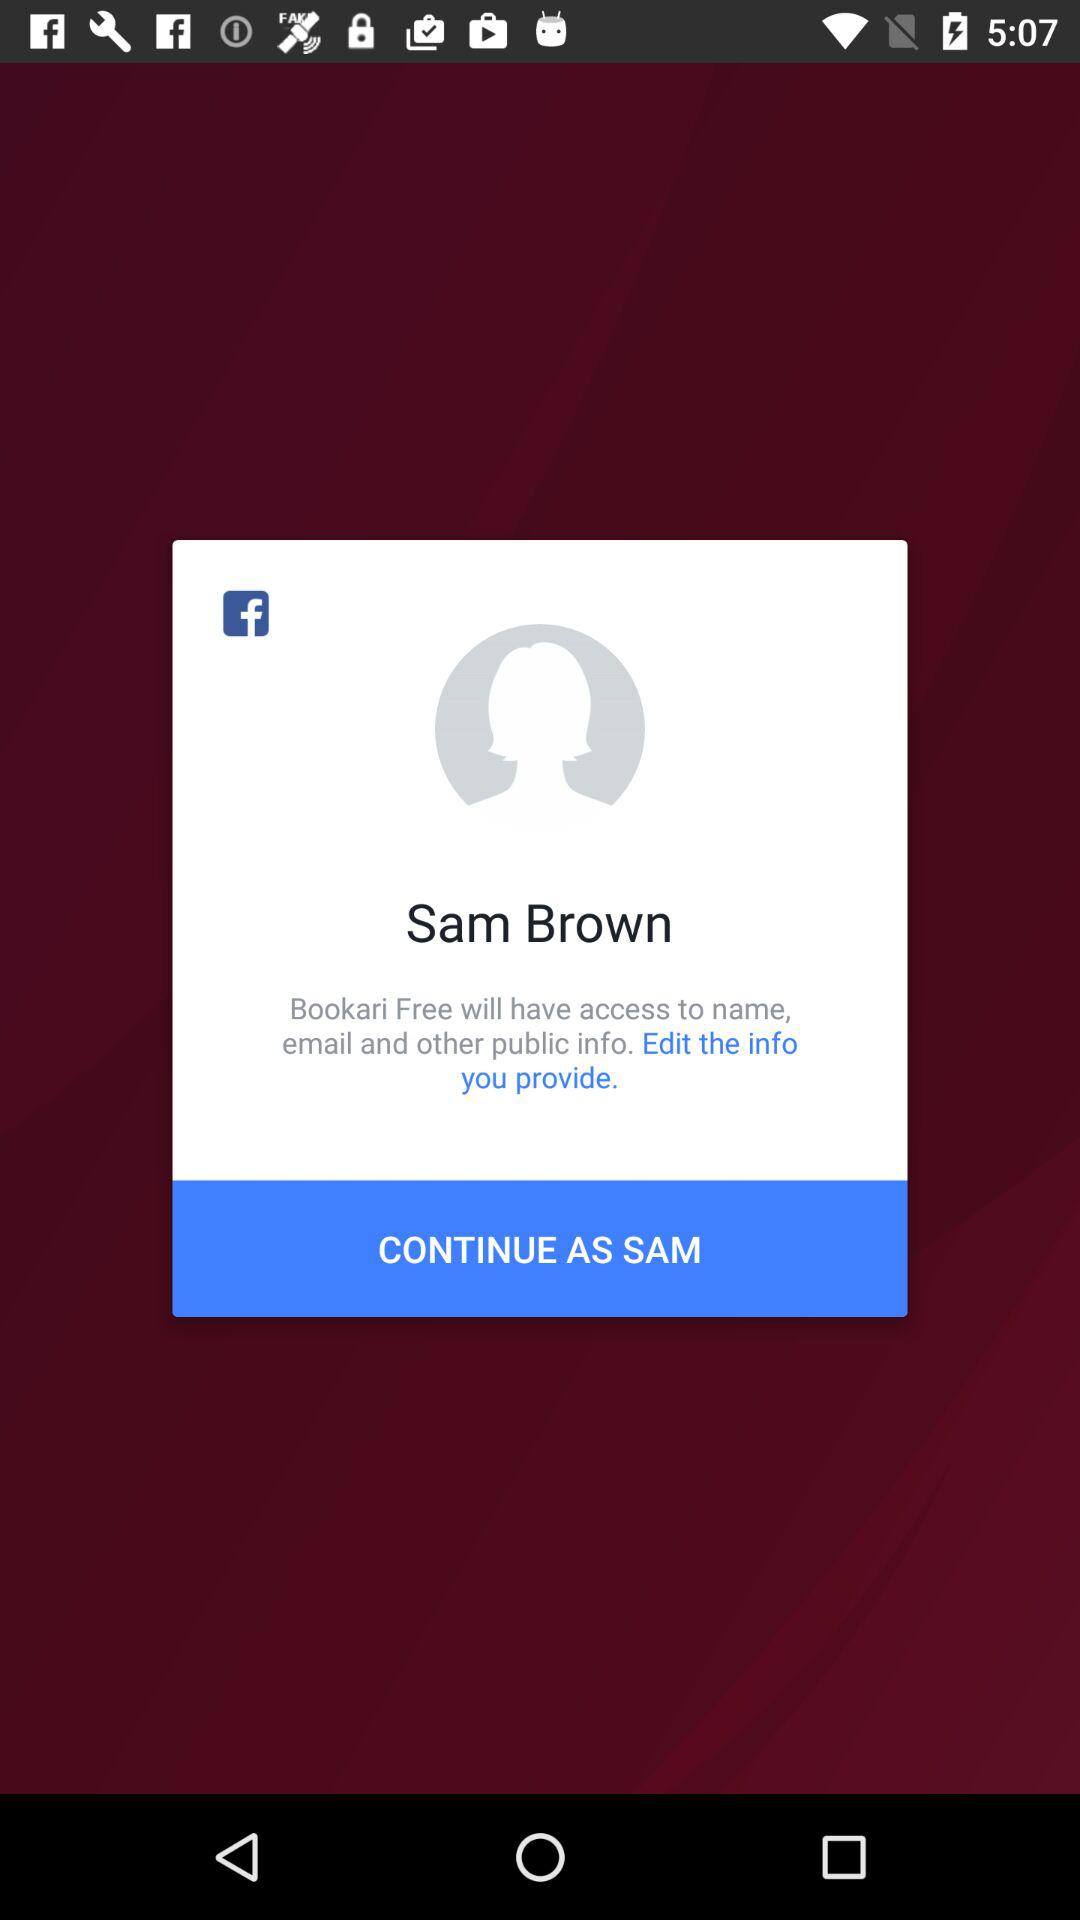What application is asking for permission? The application asking for permission is "Bookari Free". 